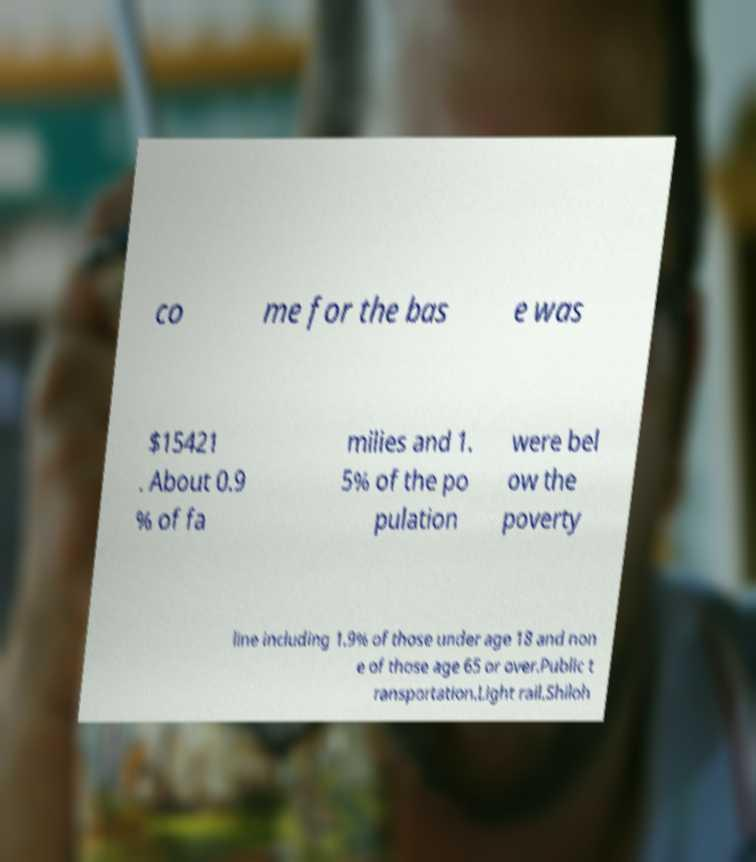There's text embedded in this image that I need extracted. Can you transcribe it verbatim? co me for the bas e was $15421 . About 0.9 % of fa milies and 1. 5% of the po pulation were bel ow the poverty line including 1.9% of those under age 18 and non e of those age 65 or over.Public t ransportation.Light rail.Shiloh 